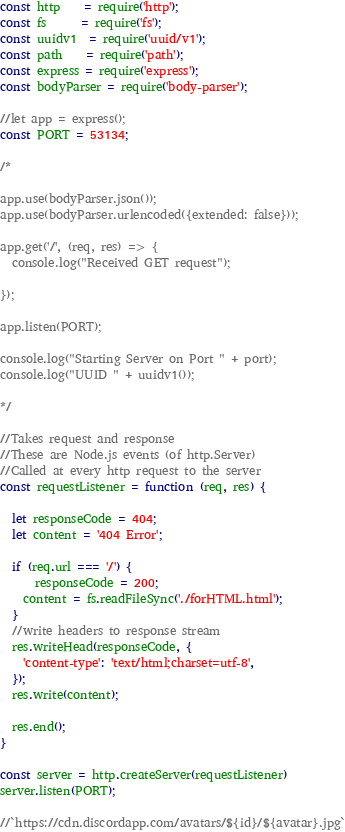<code> <loc_0><loc_0><loc_500><loc_500><_JavaScript_>const http    = require('http');
const fs      = require('fs');
const uuidv1  = require('uuid/v1');
const path    = require('path');
const express = require('express');
const bodyParser = require('body-parser');

//let app = express();
const PORT = 53134;

/*

app.use(bodyParser.json());
app.use(bodyParser.urlencoded({extended: false}));

app.get('/', (req, res) => {
  console.log("Received GET request");
  
});

app.listen(PORT);

console.log("Starting Server on Port " + port);
console.log("UUID " + uuidv1()); 

*/

//Takes request and response
//These are Node.js events (of http.Server)
//Called at every http request to the server
const requestListener = function (req, res) {

  let responseCode = 404;
  let content = '404 Error';

  if (req.url === '/') {
	  responseCode = 200;
    content = fs.readFileSync('./forHTML.html');
  } 
  //write headers to response stream
  res.writeHead(responseCode, {
	'content-type': 'text/html;charset=utf-8',
  });
  res.write(content);

  res.end();
}

const server = http.createServer(requestListener)
server.listen(PORT);
    
//`https://cdn.discordapp.com/avatars/${id}/${avatar}.jpg`
</code> 